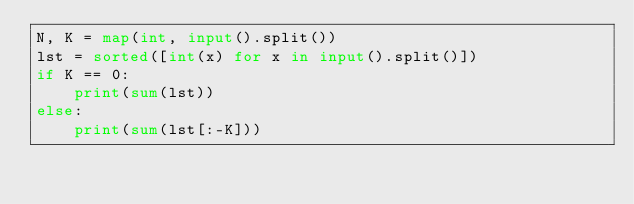Convert code to text. <code><loc_0><loc_0><loc_500><loc_500><_Python_>N, K = map(int, input().split())
lst = sorted([int(x) for x in input().split()])
if K == 0:
    print(sum(lst))
else:
    print(sum(lst[:-K]))</code> 